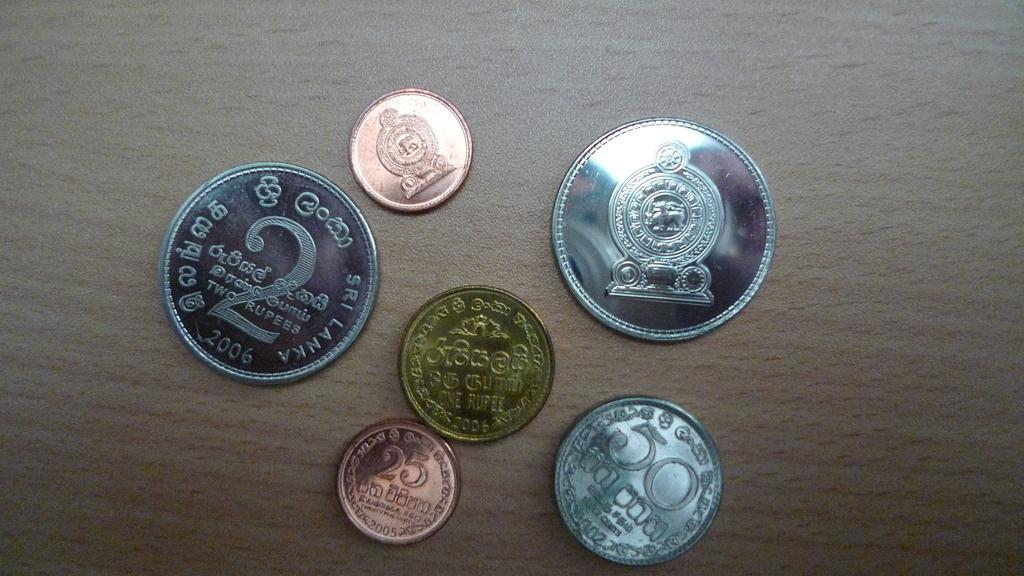<image>
Write a terse but informative summary of the picture. a table with coins on it with one of them saying '25 and 2005' 